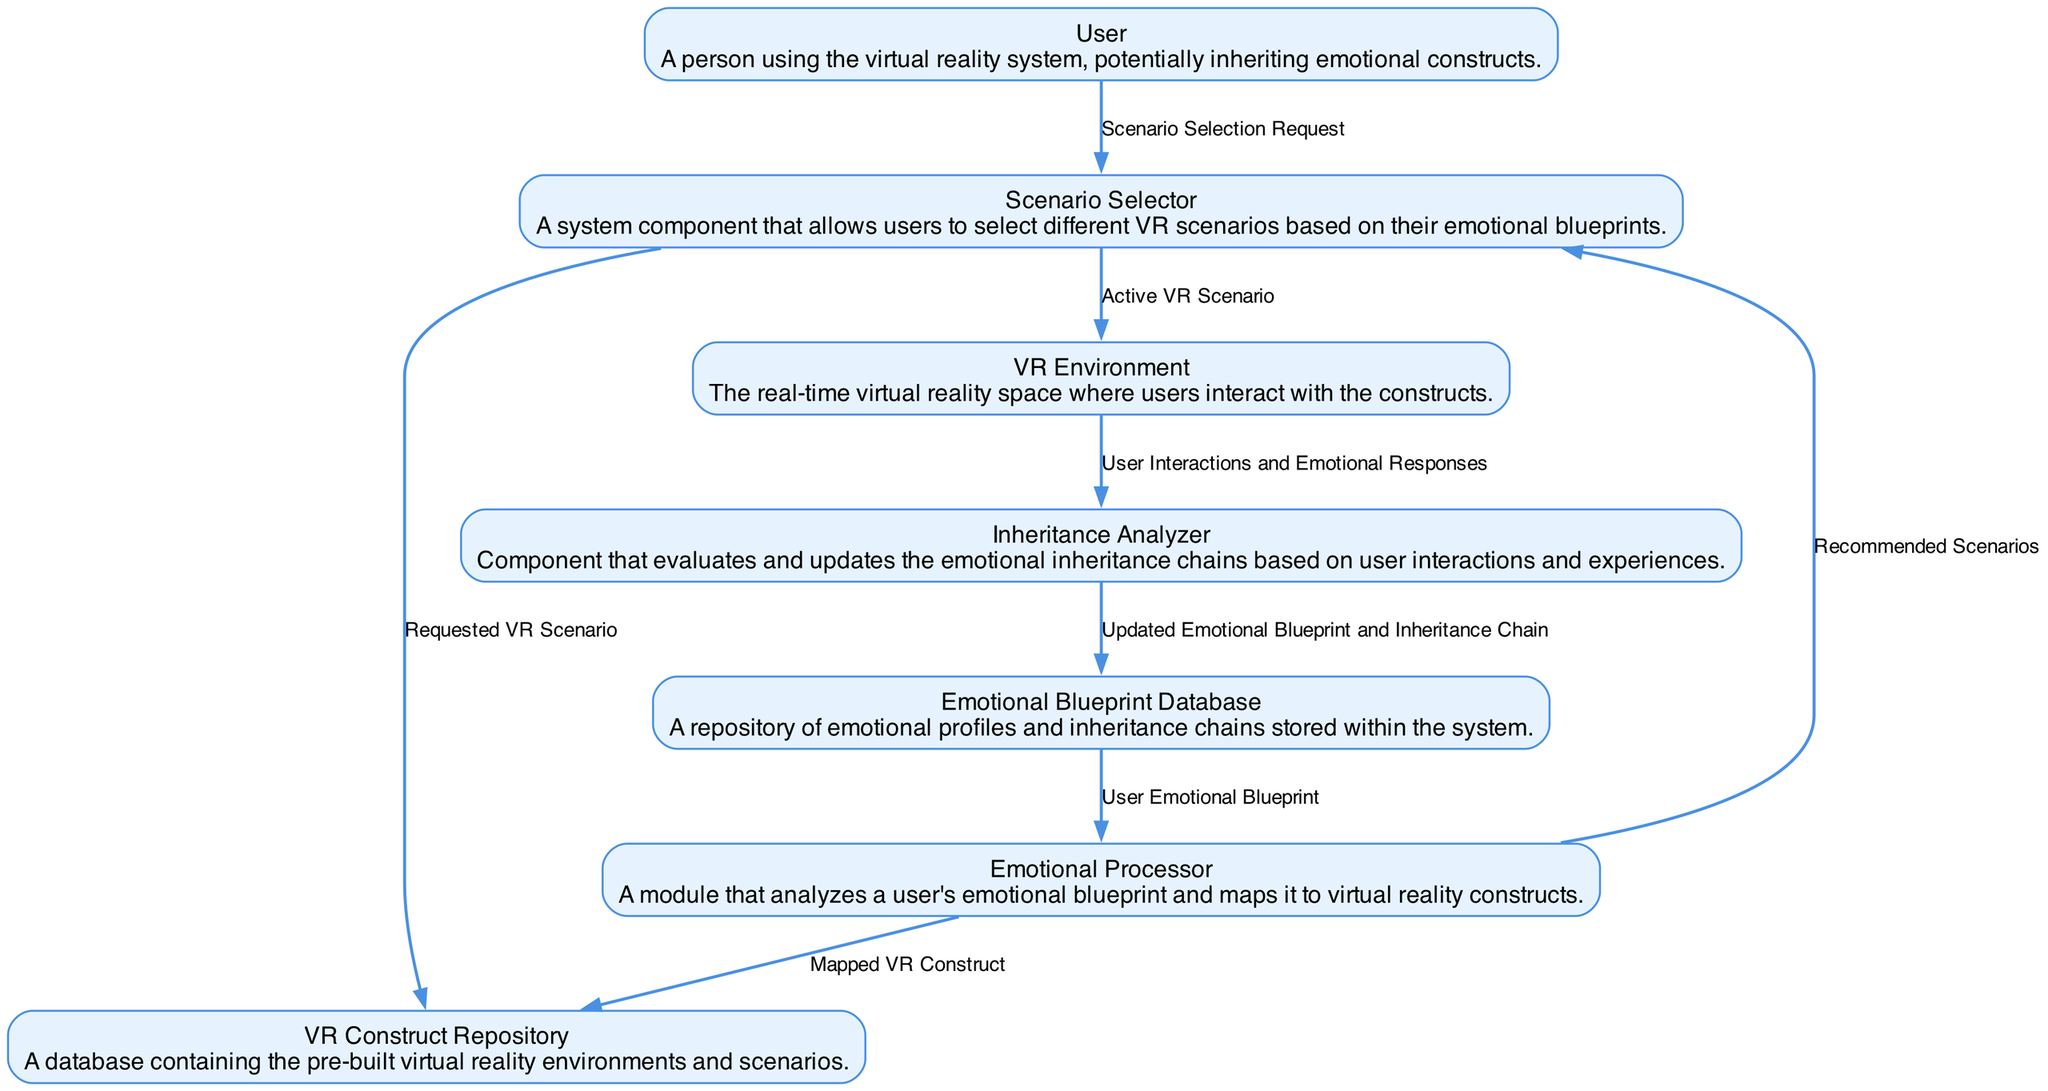What is the source of the "Scenario Selection Request"? The source of the "Scenario Selection Request" is the "User" node, as indicated by the flow direction in the diagram.
Answer: User How many nodes are present in the diagram? By counting the entities listed in the diagram, there are a total of seven nodes representing different components in the system.
Answer: 7 What data flows from the "Emotional Processor" to the "Scenario Selector"? The data that flows from the "Emotional Processor" to the "Scenario Selector" is labeled as "Recommended Scenarios," showing how emotional data influences scenario selection.
Answer: Recommended Scenarios What is the destination of the "User Interactions and Emotional Responses"? The destination of the "User Interactions and Emotional Responses" flow is the "Inheritance Analyzer," which evaluates user interactions.
Answer: Inheritance Analyzer Which component updates the emotional blueprints and inheritance chains? The component responsible for updating the emotional blueprints and inheritance chains is the "Inheritance Analyzer," as it receives interactions and modifies data accordingly.
Answer: Inheritance Analyzer What type of data does the "Scenario Selector" send to the "VR Environment"? The "Scenario Selector" sends "Active VR Scenario" data to the "VR Environment," indicating the scenario that will be presented to the user.
Answer: Active VR Scenario Which two components are directly connected through a data flow labeled "Mapped VR Construct"? The two components connected through the flow labeled "Mapped VR Construct" are the "Emotional Processor" and the "VR Construct Repository," indicating how emotional data translates into virtual scenarios.
Answer: Emotional Processor and VR Construct Repository What action does the "User" take to initiate the process in the diagram? The action taken by the "User" to initiate the process is to make a "Scenario Selection Request," which triggers the subsequent data flows within the system.
Answer: Scenario Selection Request What is the relationship between the "Emotional Processor" and the "Emotional Blueprint Database"? The relationship is that the "Emotional Processor" receives user's emotional blueprints from the "Emotional Blueprint Database," which is essential for mapping emotions to VR constructs.
Answer: Emotional blueprint retrieval 